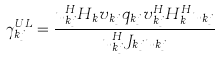<formula> <loc_0><loc_0><loc_500><loc_500>\gamma _ { k j } ^ { U L } = \frac { u _ { k j } ^ { H } H _ { k } v _ { k j } q _ { k j } v _ { k j } ^ { H } H _ { k } ^ { H } u _ { k j } } { u _ { k j } ^ { H } J _ { k j } u _ { k j } }</formula> 